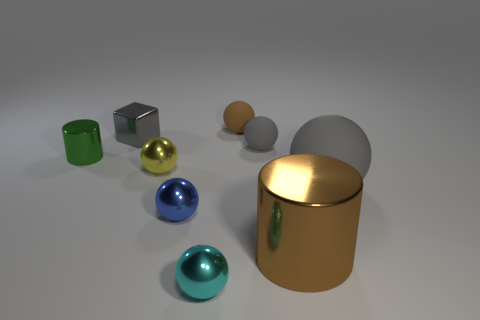What number of things are shiny objects left of the small blue shiny thing or small objects that are right of the small cyan sphere?
Provide a succinct answer. 5. How many other things are there of the same shape as the brown metallic object?
Offer a terse response. 1. There is a small metallic thing that is behind the small green thing; is it the same color as the big ball?
Offer a very short reply. Yes. How many other objects are the same size as the brown sphere?
Keep it short and to the point. 6. Do the large gray sphere and the blue sphere have the same material?
Ensure brevity in your answer.  No. There is a metal cylinder that is right of the tiny object that is left of the gray block; what is its color?
Keep it short and to the point. Brown. The other thing that is the same shape as the green metal thing is what size?
Give a very brief answer. Large. Does the metal cube have the same color as the large metal thing?
Give a very brief answer. No. How many gray things are to the right of the metal cylinder that is on the right side of the thing that is in front of the big brown cylinder?
Offer a terse response. 1. Is the number of big objects greater than the number of things?
Make the answer very short. No. 